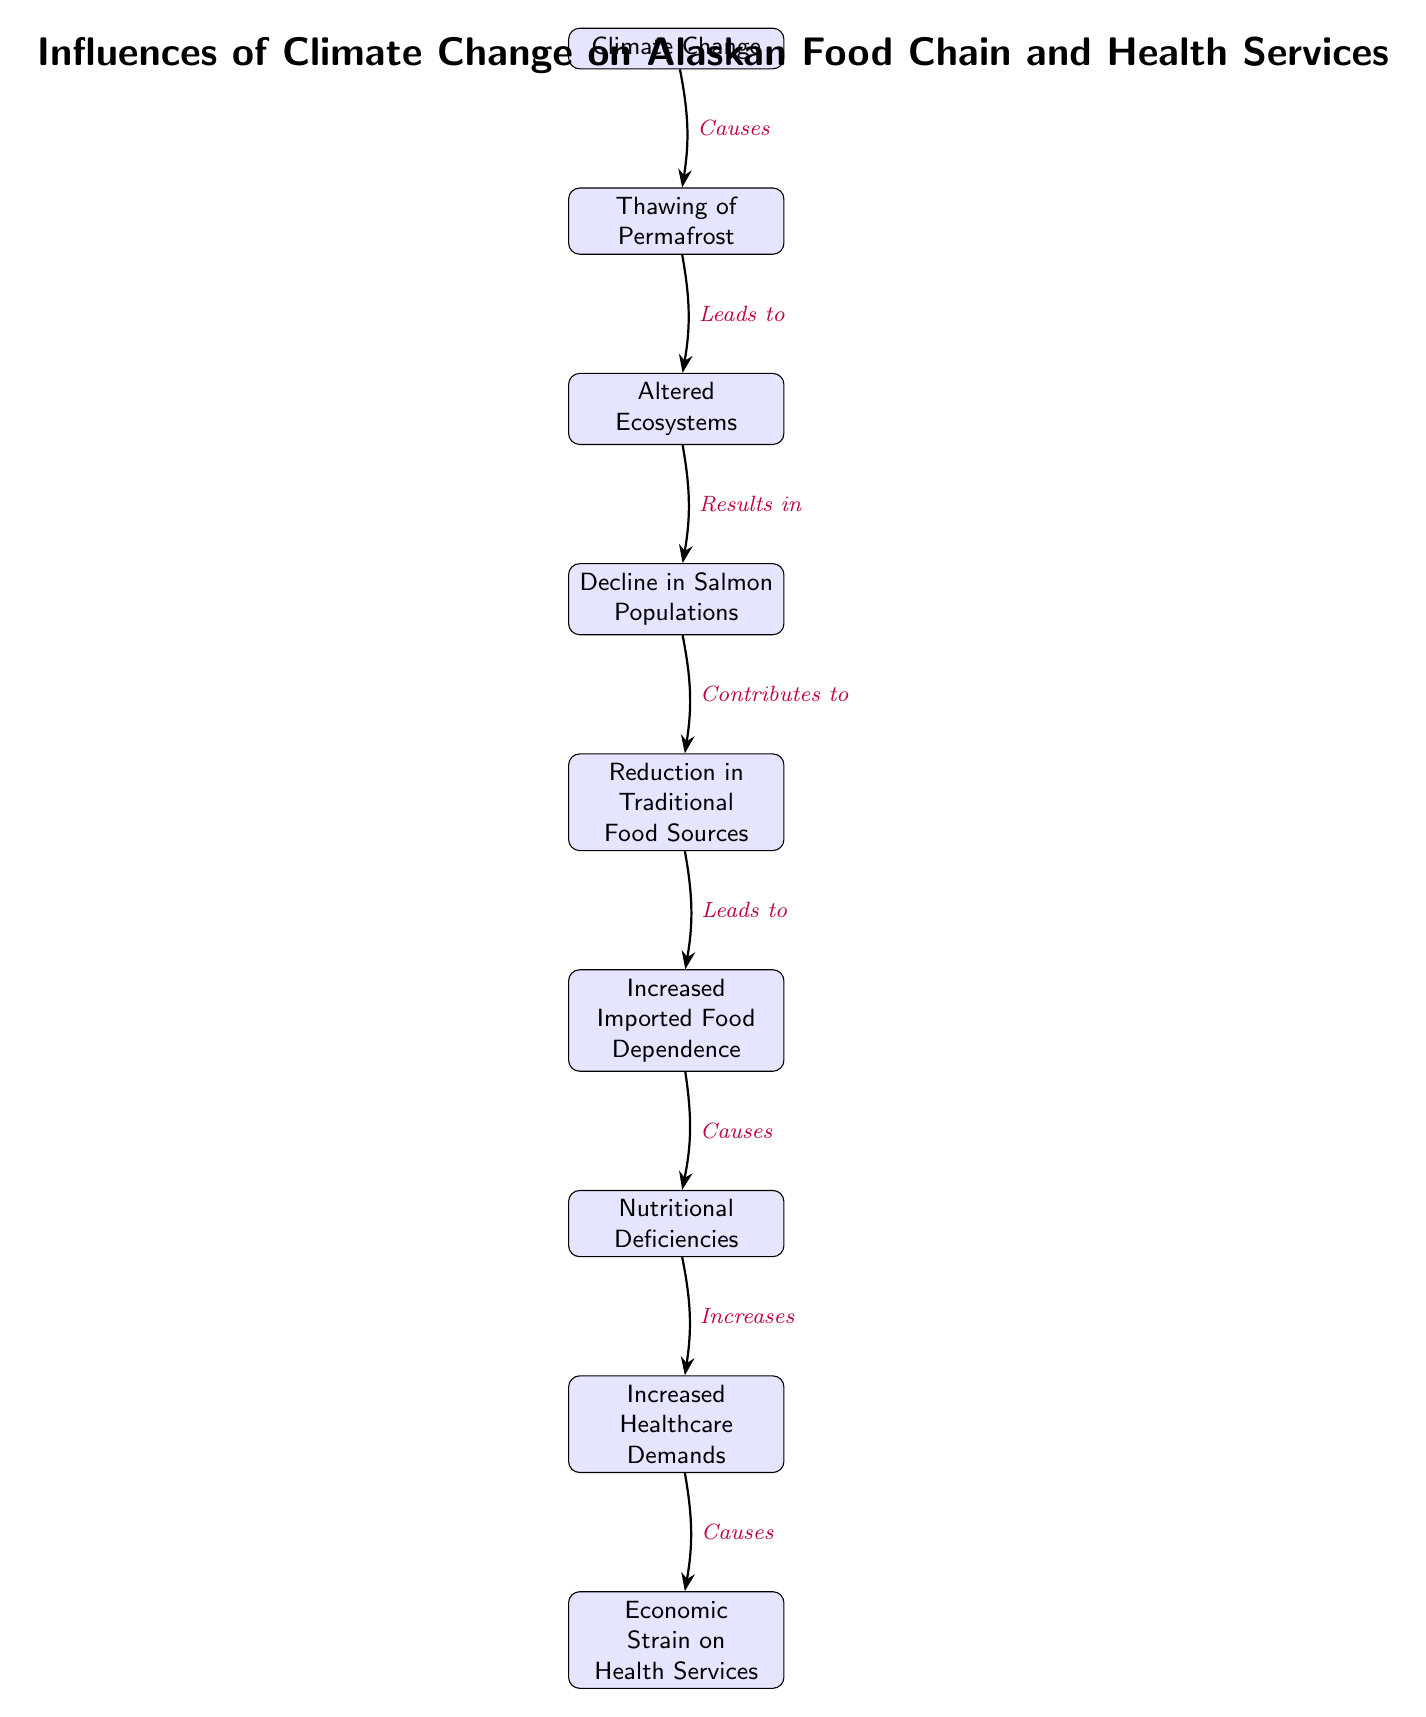What is the starting node in the diagram? The starting node is "Climate Change", which is the primary influence in this food chain, leading to various effects illustrated in subsequent nodes.
Answer: Climate Change How many nodes are present in the diagram? By counting each box in the diagram, we find a total of nine nodes representing different aspects of the influence of climate change on health services.
Answer: 9 What is the immediate effect of thawing of permafrost? The immediate effect following "Thawing of Permafrost" is "Altered Ecosystems," indicating how permafrost melting affects environmental and ecological conditions.
Answer: Altered Ecosystems What do nutritional deficiencies lead to? According to the flow of the diagram, "Nutritional Deficiencies" lead to "Increased Healthcare Demands," showing the direct connection between diet and health service needs.
Answer: Increased Healthcare Demands What contributes to the reduction of traditional food sources? The node "Decline in Salmon Populations" directly contributes to "Reduction in Traditional Food Sources," emphasizing the significance of salmon as a staple in local diets.
Answer: Decline in Salmon Populations How does increased imported food dependence relate to nutritional deficiencies? "Increased Imported Food Dependence" causes "Nutritional Deficiencies", implying that reliance on imported foods may lack essential nutrients compared to traditional sources.
Answer: Causes What is the final outcome presented in the diagram? The last node in the diagram is "Economic Strain on Health Services," representing the ultimate consequence of the preceding influences in the food chain.
Answer: Economic Strain on Health Services What relationship does thawing of permafrost have with climate change? The relationship is that "Thawing of Permafrost" is a direct consequence or effect arising from "Climate Change," indicating a cause-and-effect relationship in the diagram.
Answer: Leads to How many direct consequences stem from the "Climate Change" node? The "Climate Change" node leads directly to one consequence, which is the "Thawing of Permafrost.", showcasing a straightforward chain of influence.
Answer: 1 What node follows "Reduction in Traditional Food Sources"? Directly below "Reduction in Traditional Food Sources" is the "Increased Imported Food Dependence" node, highlighting the sequence of dependency in food resources.
Answer: Increased Imported Food Dependence 